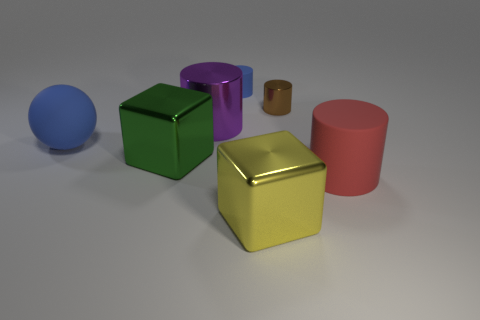Subtract 1 cylinders. How many cylinders are left? 3 Add 1 big cyan rubber cylinders. How many objects exist? 8 Subtract all blocks. How many objects are left? 5 Add 2 cylinders. How many cylinders are left? 6 Add 5 big green blocks. How many big green blocks exist? 6 Subtract 1 purple cylinders. How many objects are left? 6 Subtract all small metal cylinders. Subtract all big brown shiny cylinders. How many objects are left? 6 